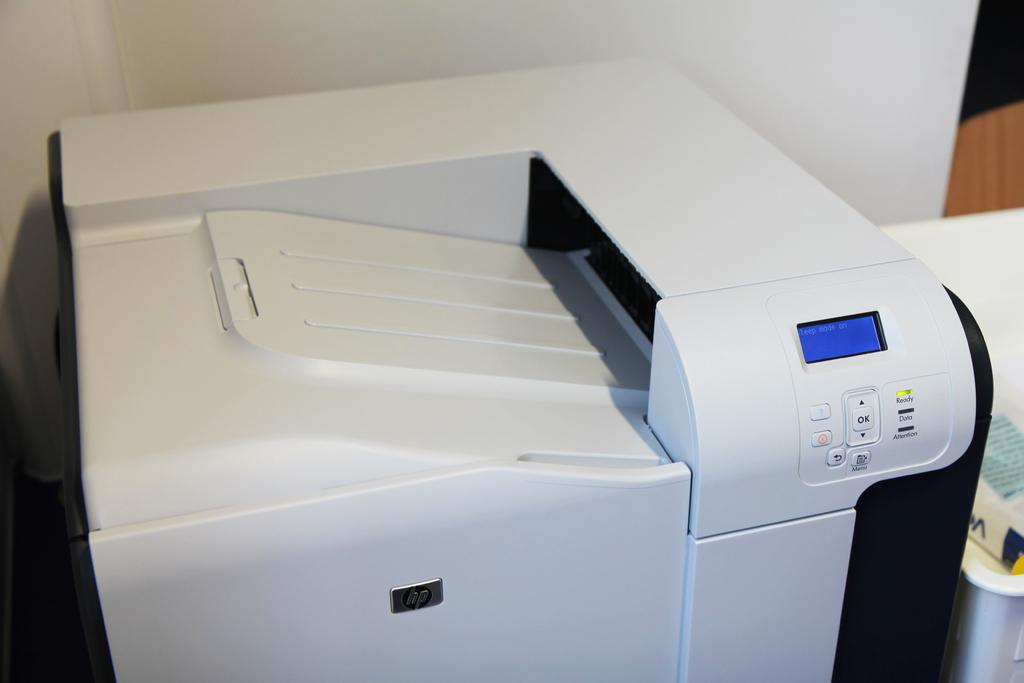<image>
Render a clear and concise summary of the photo. A printer has the ready LED on, but the blue screen shows the sleep mode is on. 